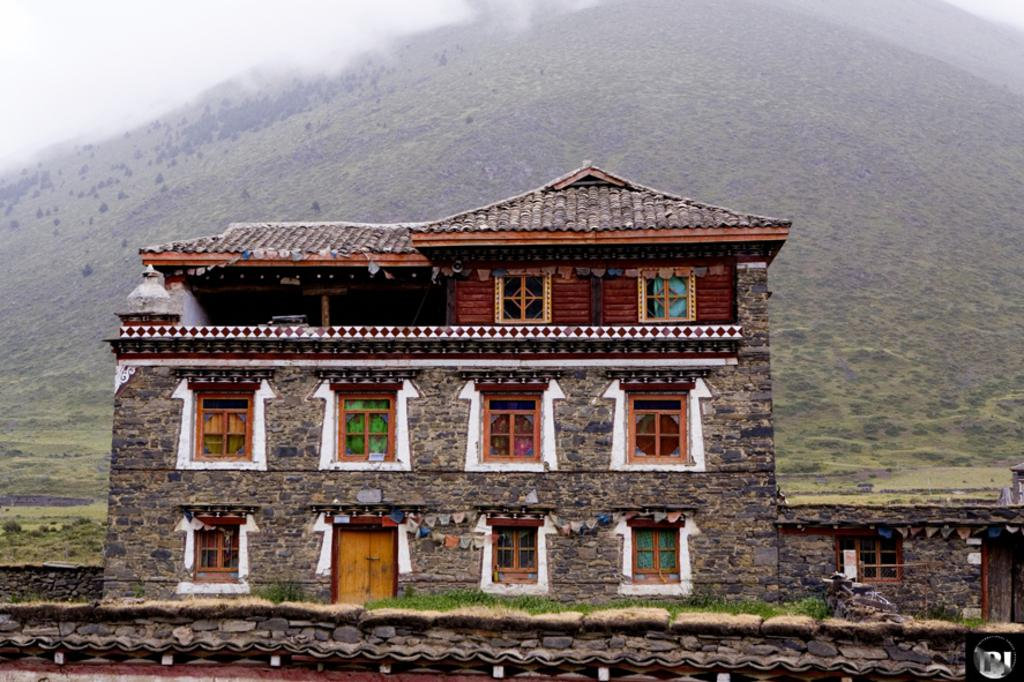What type of structure is visible in the image? There is a building in the image. What features can be seen on the building? The building has windows and doors. What is visible in the background of the image? There is a hill in the background of the image. What atmospheric condition is present in the image? There is fog in the image. What type of rings can be seen on the shirt of the person in the image? There is no person or shirt present in the image, so no rings can be seen. 